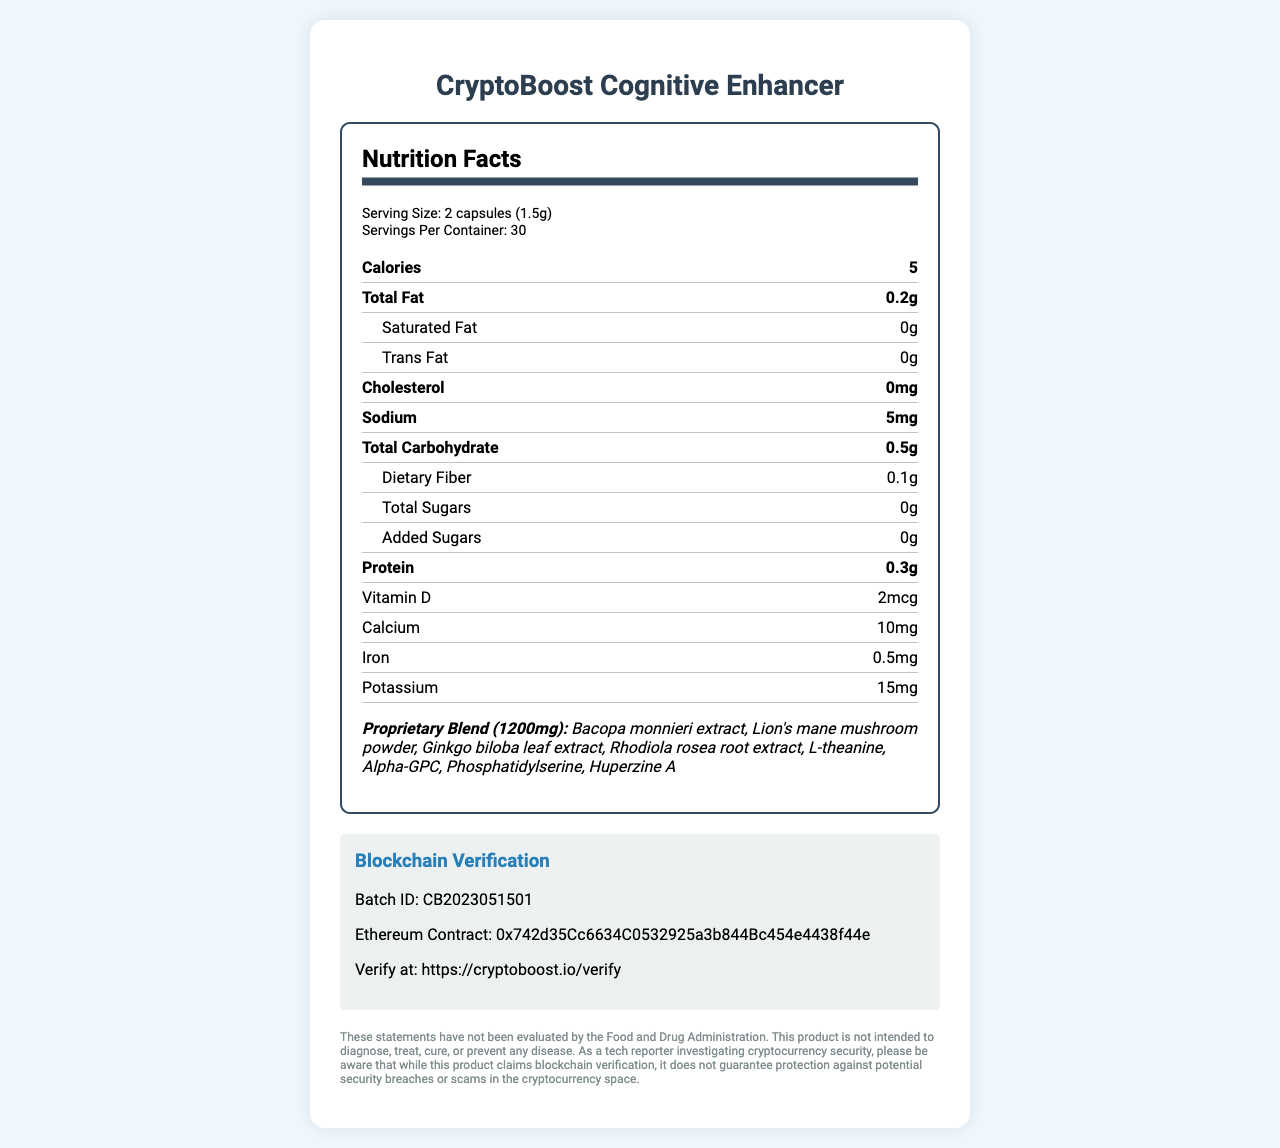what is the serving size of CryptoBoost Cognitive Enhancer? The serving size is mentioned at the top under Serving Size: 2 capsules (1.5g).
Answer: 2 capsules (1.5g) how many servings are there in one container? The number of servings per container is directly mentioned beneath the serving size.
Answer: 30 what is the batch ID for the blockchain verification? The batch ID is found in the Blockchain Verification section under Batch ID.
Answer: CB2023051501 what is the amount of sodium per serving? The sodium content per serving is detailed in the main nutrients list as Sodium: 5mg.
Answer: 5mg which vitamin has the highest amount in the supplement? Among the listed vitamins, Niacin has the highest amount at 16mg.
Answer: Niacin which is NOT one of the proprietary blend ingredients? A. Bacopa monnieri extract B. Ginkgo biloba leaf extract C. Caffeine The proprietary blend ingredients are listed, and Caffeine is not included among them.
Answer: C. Caffeine how many security features are listed for CryptoBoost Cognitive Enhancer? A. 1 B. 2 C. 3 D. 4 There are three security features listed: tamper-evident seal, holographic label, and QR code authentication.
Answer: C. 3 is this product intended to diagnose, treat, cure, or prevent any disease? The disclaimer clearly states that the product is not intended to diagnose, treat, cure, or prevent any disease.
Answer: No describe the main idea of the document. The document includes nutritional information, ingredients, proprietary blend components, blockchain verification details, security features, and a disclaimer about the product's intent.
Answer: The document provides a detailed nutritional analysis of the CryptoBoost Cognitive Enhancer supplement, highlights blockchain verification details, security features, and includes a disclaimer. does the document specify the manufacture date? The document does not include any manufacture date information.
Answer: No what is the form of the capsule mentioned in the other ingredients section? The other ingredients list includes Vegetable cellulose (capsule).
Answer: Vegetable cellulose what is the total weight of the proprietary blend in each serving? The total weight of the proprietary blend is given as 1200mg.
Answer: 1200mg what type of facility is the product manufactured in regarding allergen information? This information is found under the allergen information section.
Answer: A facility that also processes soy, tree nuts, and shellfish how can you verify the batch of the product? The blockchain verification section provides a URL and the batch ID to verify the product.
Answer: By visiting https://cryptoboost.io/verify and using the batch ID CB2023051501 what is the Ethereum contract address for the blockchain verification? It is found in the Blockchain Verification section under Ethereum Contract.
Answer: 0x742d35Cc6634C0532925a3b844Bc454e4438f44e 